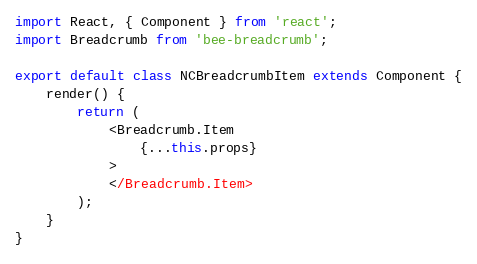Convert code to text. <code><loc_0><loc_0><loc_500><loc_500><_JavaScript_>import React, { Component } from 'react';
import Breadcrumb from 'bee-breadcrumb';

export default class NCBreadcrumbItem extends Component {
	render() {
		return (
			<Breadcrumb.Item
                {...this.props} 
			>
            </Breadcrumb.Item>
		);
	}
}</code> 